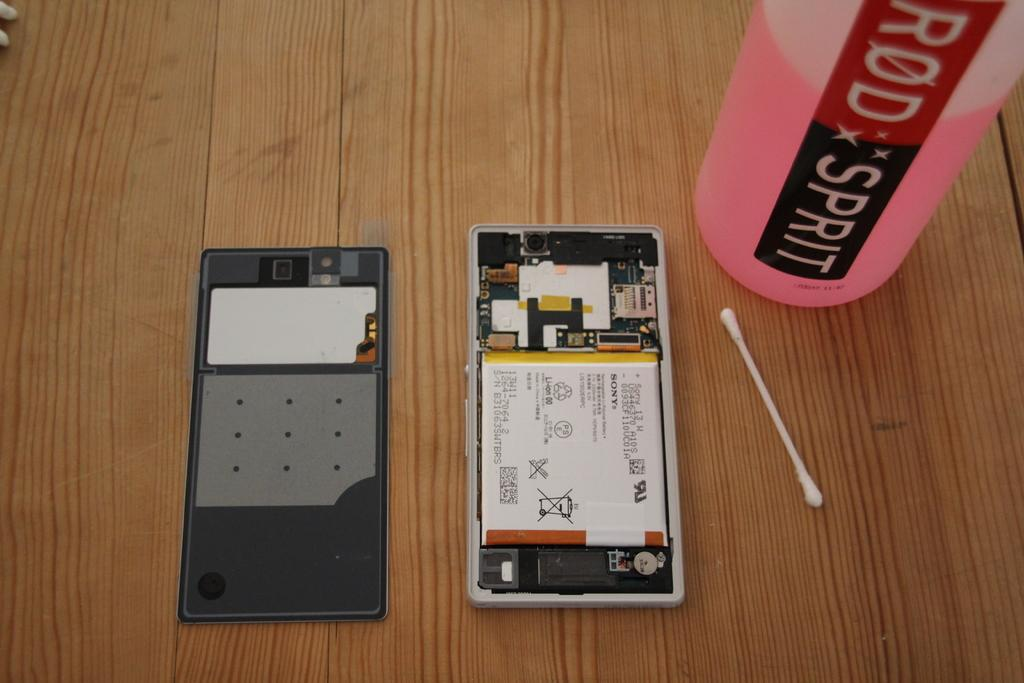What object is located on the left side of the image? There is a cup on the left side of the image. What type of device can be seen in the image? There is a mobile in the image. What material is the table made of in the image? The wooden table is present in the image. Can you describe the ear drum in the image? There is an ear drum in the image, which is a part of the human ear. What is the color of the liquid in the bottle in the image? There is a bottle with pink liquid in the image. Where is the jail located in the image? There is no jail present in the image. What type of can is visible in the image? There is no can present in the image. 